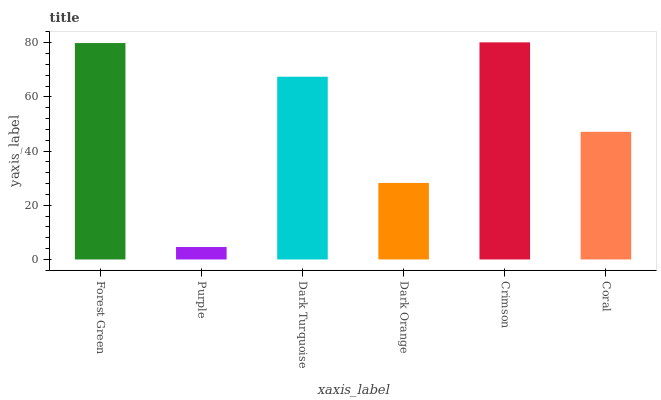Is Dark Turquoise the minimum?
Answer yes or no. No. Is Dark Turquoise the maximum?
Answer yes or no. No. Is Dark Turquoise greater than Purple?
Answer yes or no. Yes. Is Purple less than Dark Turquoise?
Answer yes or no. Yes. Is Purple greater than Dark Turquoise?
Answer yes or no. No. Is Dark Turquoise less than Purple?
Answer yes or no. No. Is Dark Turquoise the high median?
Answer yes or no. Yes. Is Coral the low median?
Answer yes or no. Yes. Is Dark Orange the high median?
Answer yes or no. No. Is Dark Turquoise the low median?
Answer yes or no. No. 